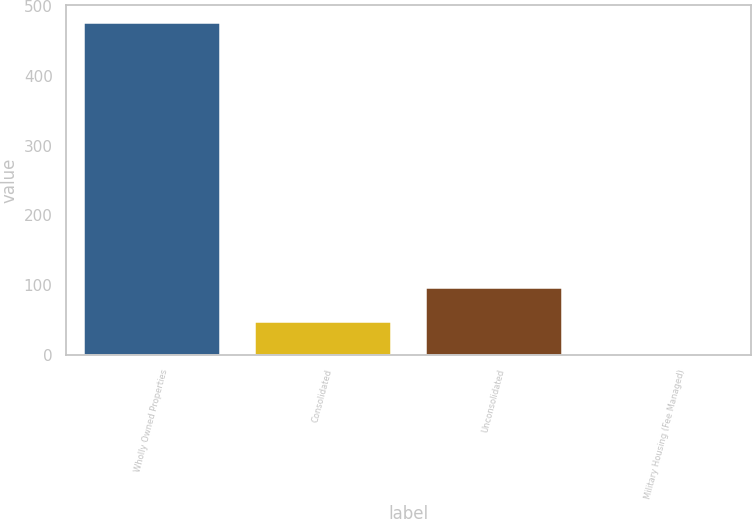Convert chart. <chart><loc_0><loc_0><loc_500><loc_500><bar_chart><fcel>Wholly Owned Properties<fcel>Consolidated<fcel>Unconsolidated<fcel>Military Housing (Fee Managed)<nl><fcel>477<fcel>49.5<fcel>97<fcel>2<nl></chart> 